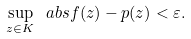<formula> <loc_0><loc_0><loc_500><loc_500>\sup _ { z \in K } \ a b s { f ( z ) - p ( z ) } < \varepsilon .</formula> 